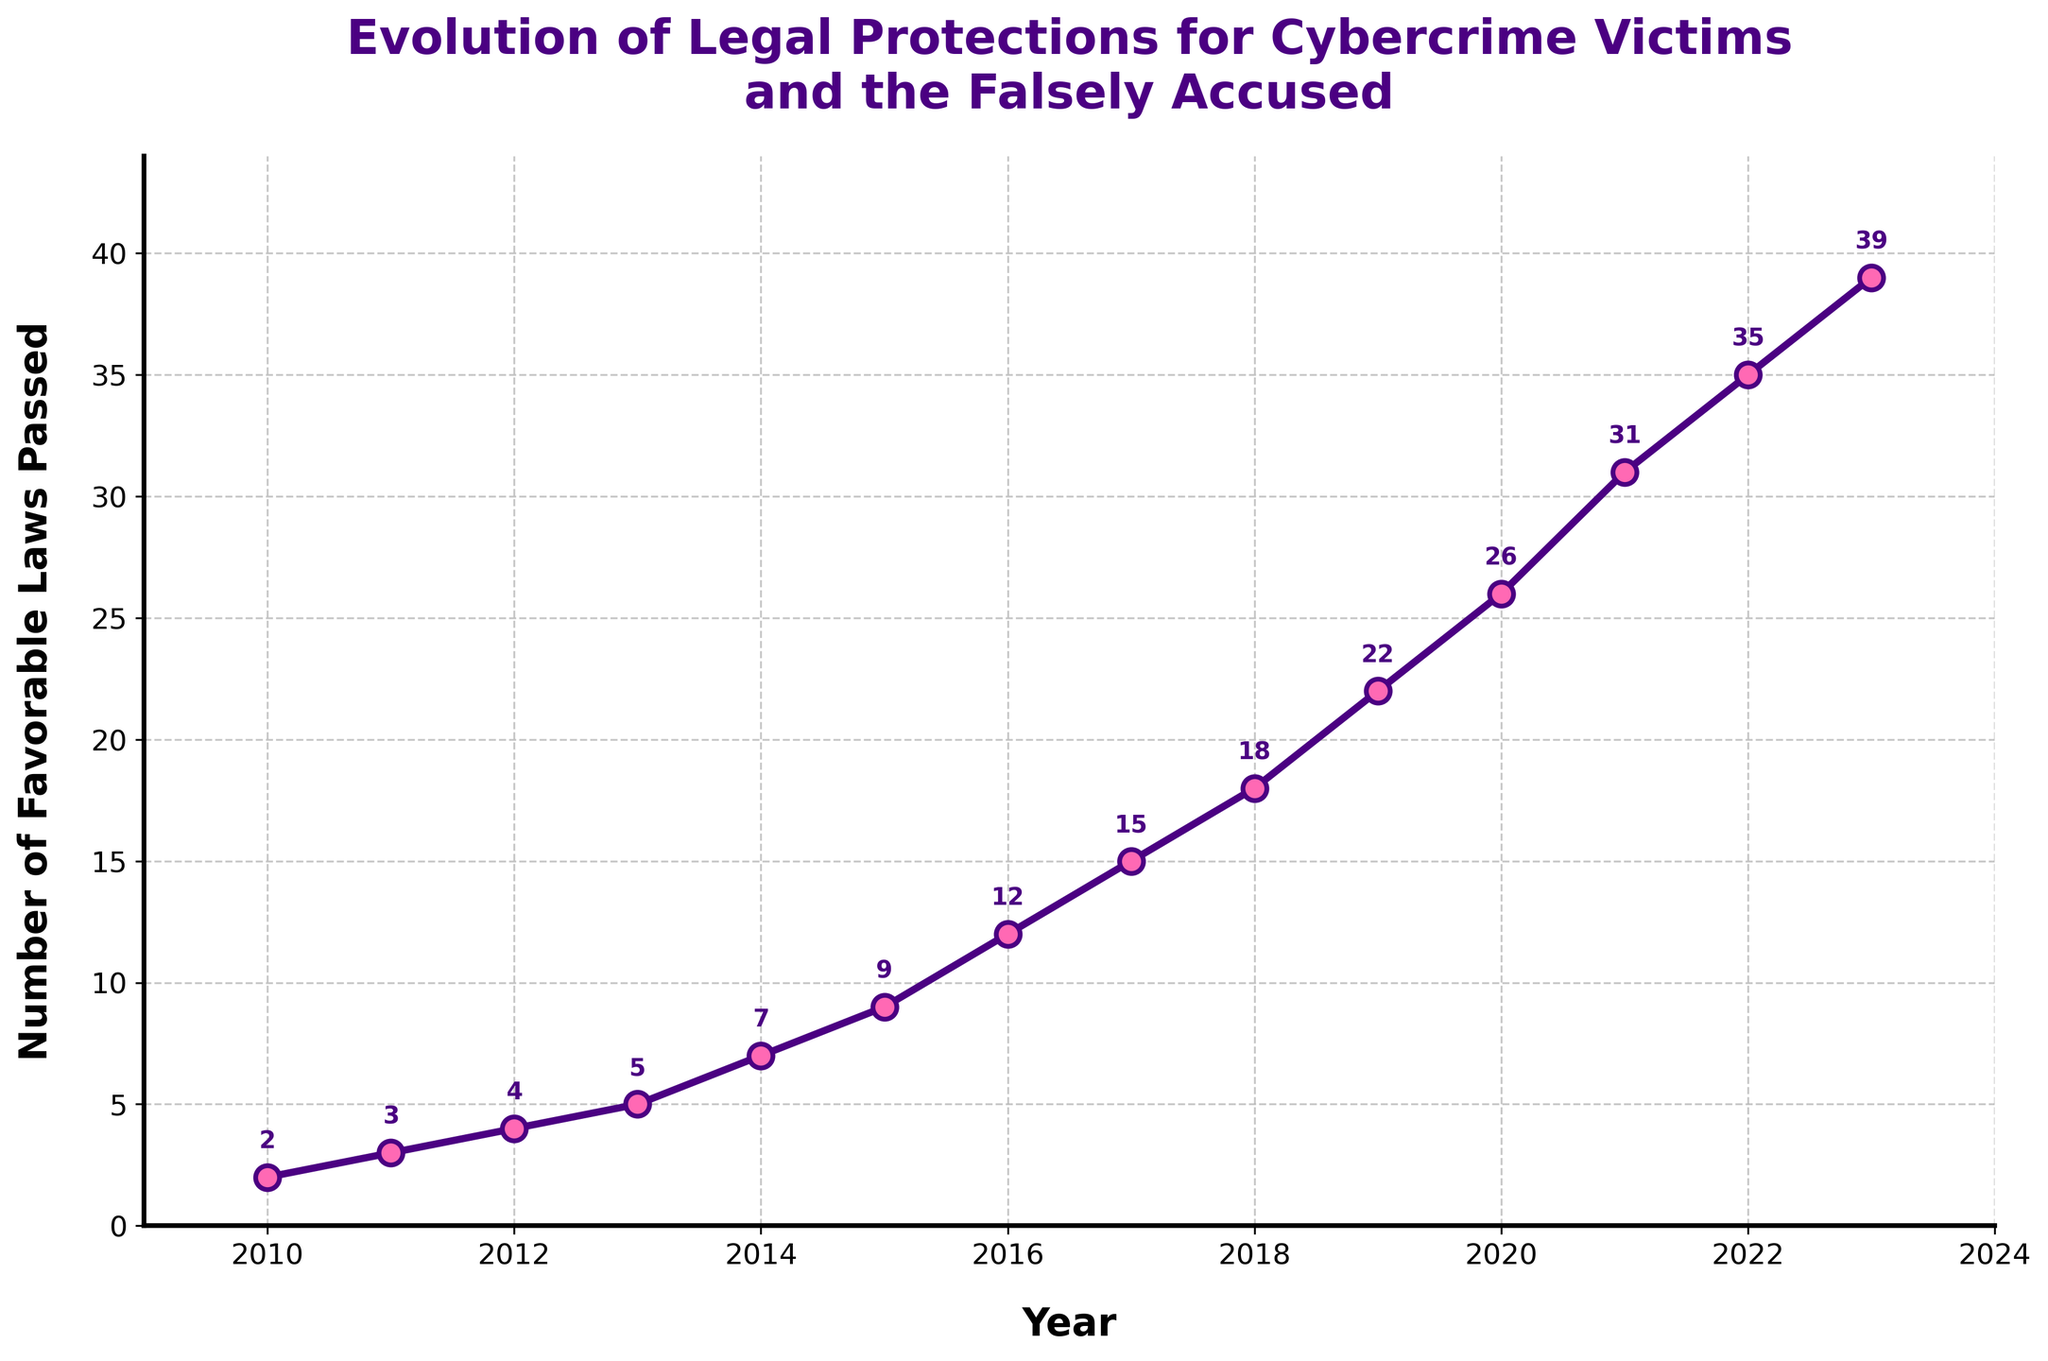What is the total number of favorable laws passed in 2023? From the figure, locate the data point corresponding to the year 2023. The number of favorable laws passed is explicitly annotated next to the data point.
Answer: 39 In which year did the number of favorable laws passed first exceed 20? From the figure, find the first data point where the number of favorable laws crossed 20. By examining the annotations, this happens in 2019.
Answer: 2019 What is the average number of favorable laws passed per year from 2010 to 2015? Sum the number of favorable laws passed from 2010 to 2015 (2+3+4+5+7+9) which equals 30. Divide by the number of years (6) to obtain the average.
Answer: 5 Between which consecutive years was the largest increase in the number of favorable laws passed? Calculate the difference in the number of favorable laws between each pair of consecutive years and identify the largest difference. The largest increase is from 2021 to 2022 (35 - 31 = 4).
Answer: 2021 to 2022 Is the trend of the number of favorable laws passed generally increasing, decreasing, or stable over the years? By observing the overall trend of the line graph, the number of favorable laws passed increases each year, indicating an increasing trend.
Answer: Increasing What is the difference in the number of favorable laws passed between 2016 and 2020? Locate the data points for 2016 and 2020 in the figure. The difference is 26 (2020) - 12 (2016) = 14.
Answer: 14 Which year had the highest number of favorable laws passed? Find the data point with the highest value. The data for 2023 shows the highest number, which is 39.
Answer: 2023 What was the cumulative number of favorable laws passed by the end of 2014? Sum the number of favorable laws passed from 2010 to 2014 (2+3+4+5+7), which equals 21.
Answer: 21 How many favorable laws were passed in the first half of the depicted period (2010-2016)? Sum the number of favorable laws passed from 2010 through 2016 (2+3+4+5+7+9+12), which equals 42.
Answer: 42 